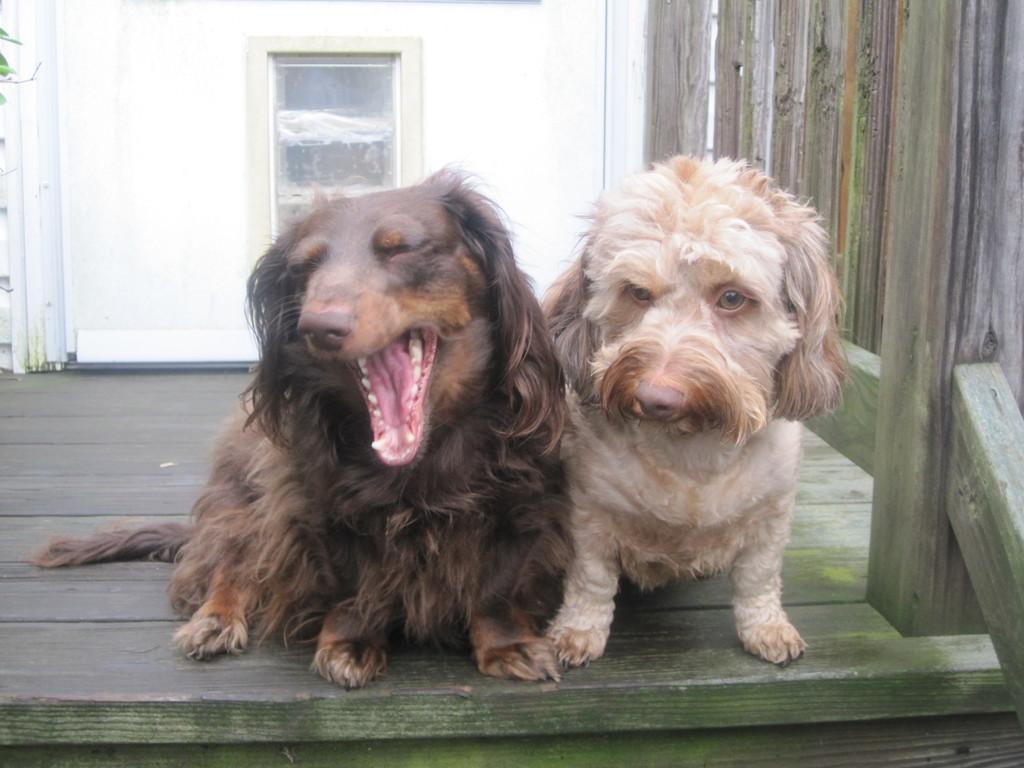How would you summarize this image in a sentence or two? In this picture we can see dogs sitting on the wood, behind we can see a glass door to the wall. 